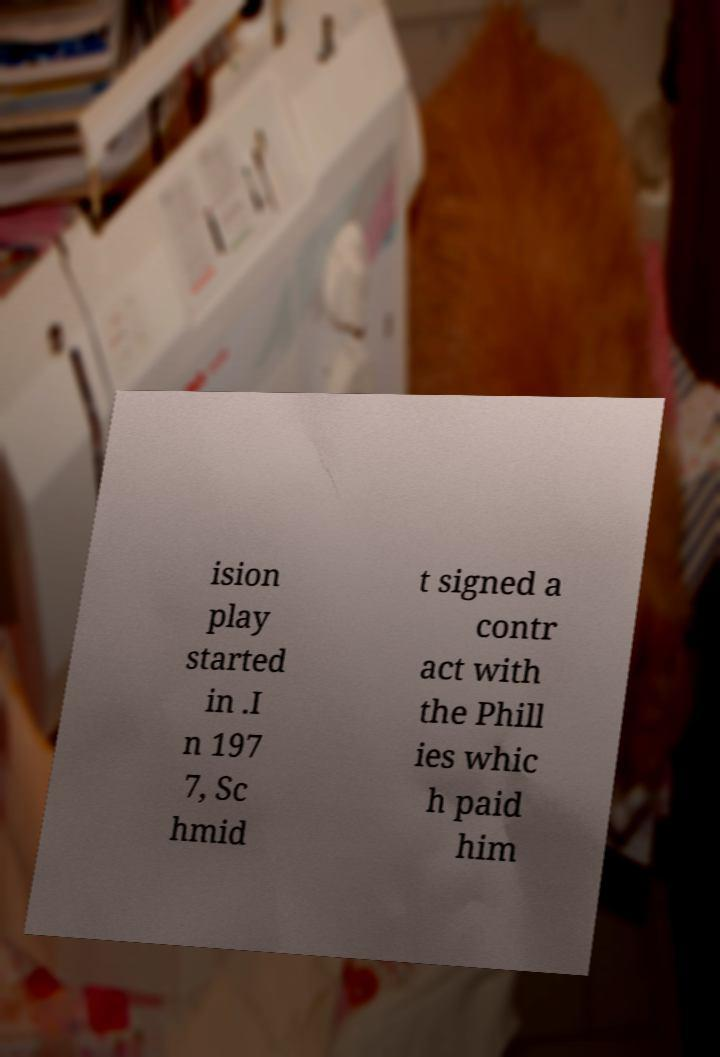Could you assist in decoding the text presented in this image and type it out clearly? ision play started in .I n 197 7, Sc hmid t signed a contr act with the Phill ies whic h paid him 